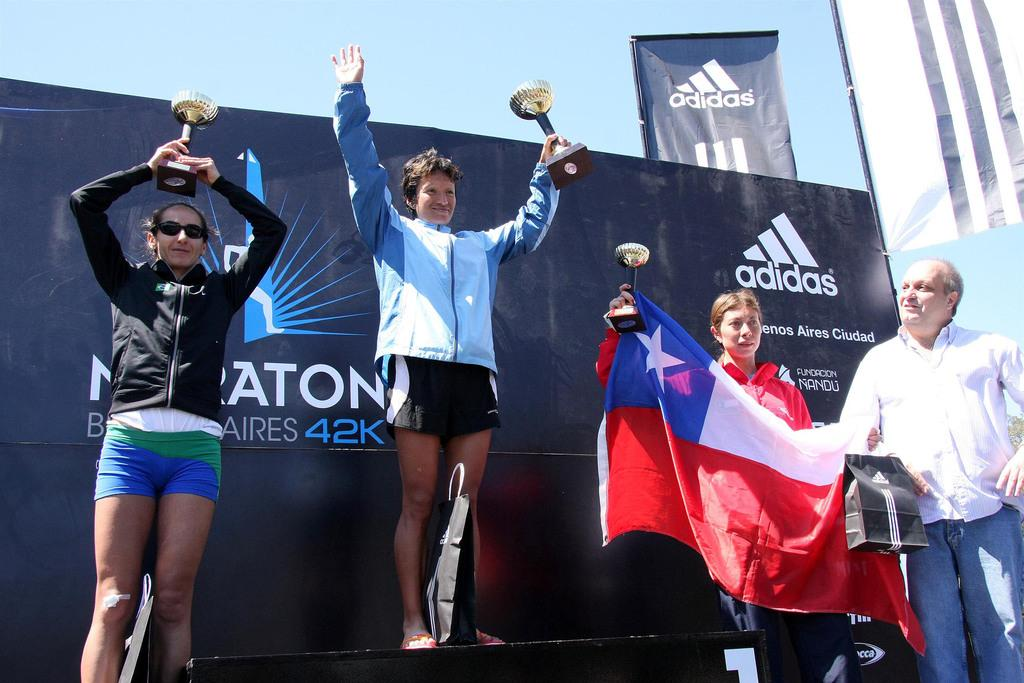Provide a one-sentence caption for the provided image. The winner of the Buenos Aires marathon celebrates her victory on a podium. 